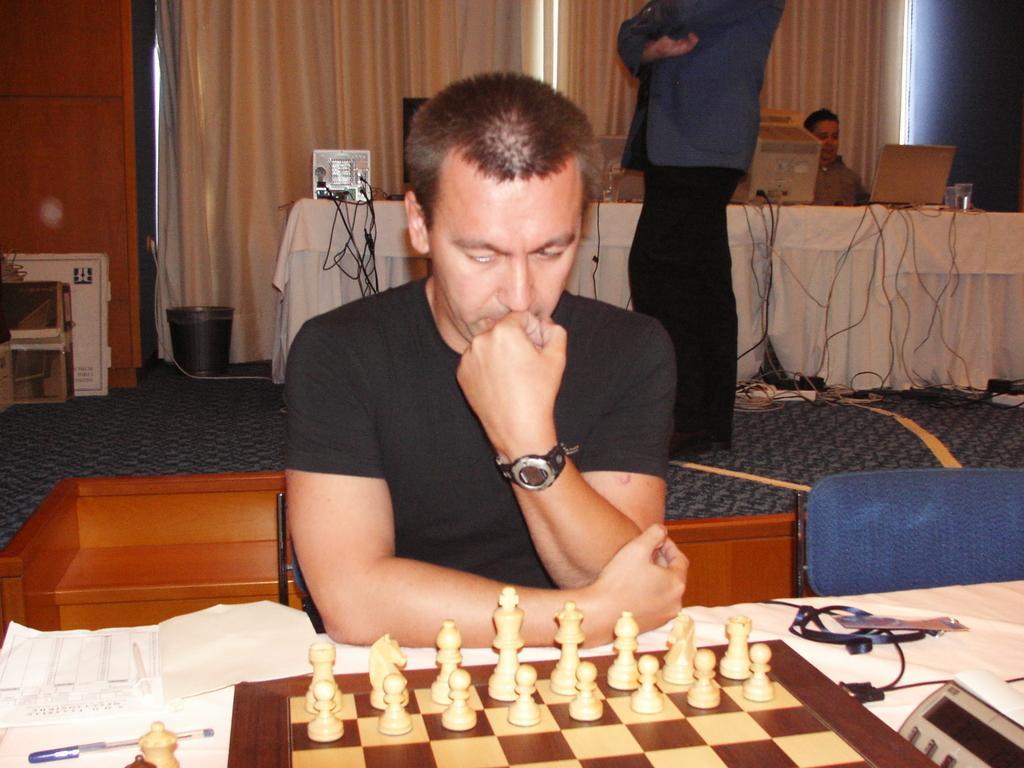Could you give a brief overview of what you see in this image? In this image a man is sitting on a chair. In front of him there is a chess board. He is wearing black t-shirt. In the background there is table on it there are laptop, desktop. A person is standing behind the man. In the background there are curtains. 